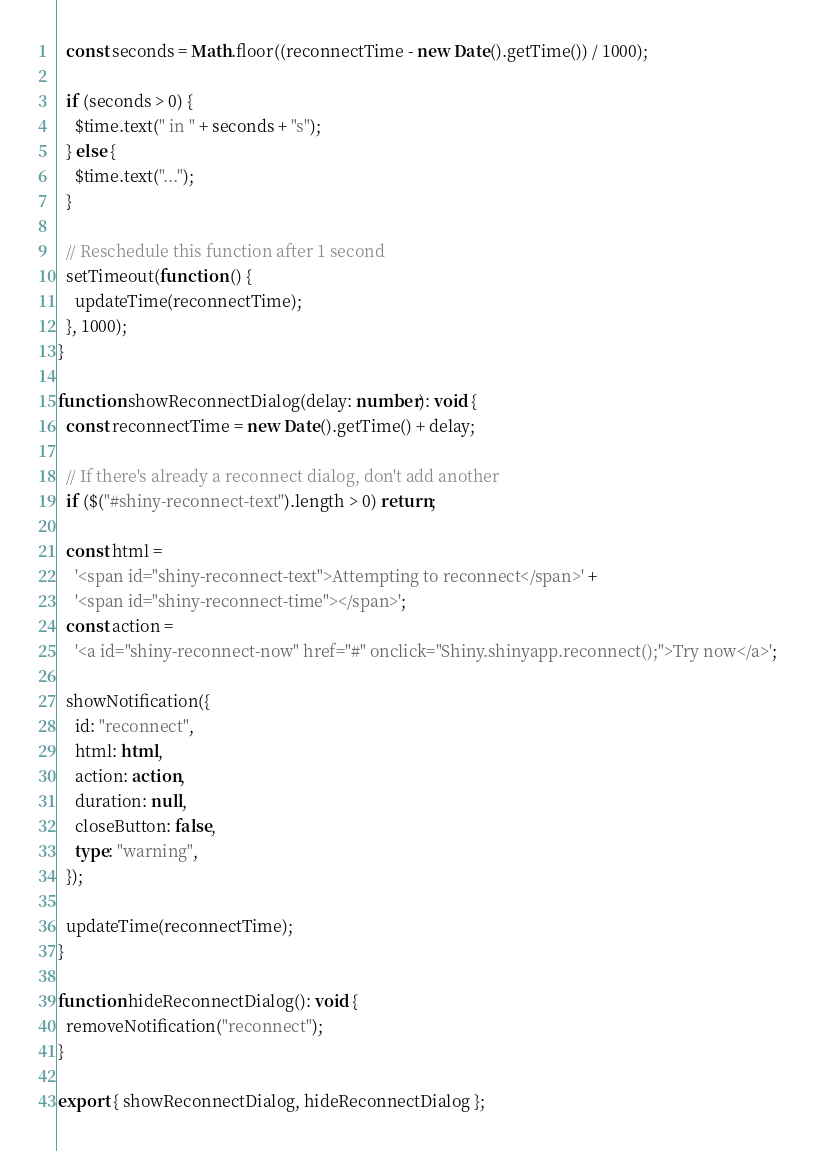Convert code to text. <code><loc_0><loc_0><loc_500><loc_500><_TypeScript_>
  const seconds = Math.floor((reconnectTime - new Date().getTime()) / 1000);

  if (seconds > 0) {
    $time.text(" in " + seconds + "s");
  } else {
    $time.text("...");
  }

  // Reschedule this function after 1 second
  setTimeout(function () {
    updateTime(reconnectTime);
  }, 1000);
}

function showReconnectDialog(delay: number): void {
  const reconnectTime = new Date().getTime() + delay;

  // If there's already a reconnect dialog, don't add another
  if ($("#shiny-reconnect-text").length > 0) return;

  const html =
    '<span id="shiny-reconnect-text">Attempting to reconnect</span>' +
    '<span id="shiny-reconnect-time"></span>';
  const action =
    '<a id="shiny-reconnect-now" href="#" onclick="Shiny.shinyapp.reconnect();">Try now</a>';

  showNotification({
    id: "reconnect",
    html: html,
    action: action,
    duration: null,
    closeButton: false,
    type: "warning",
  });

  updateTime(reconnectTime);
}

function hideReconnectDialog(): void {
  removeNotification("reconnect");
}

export { showReconnectDialog, hideReconnectDialog };
</code> 